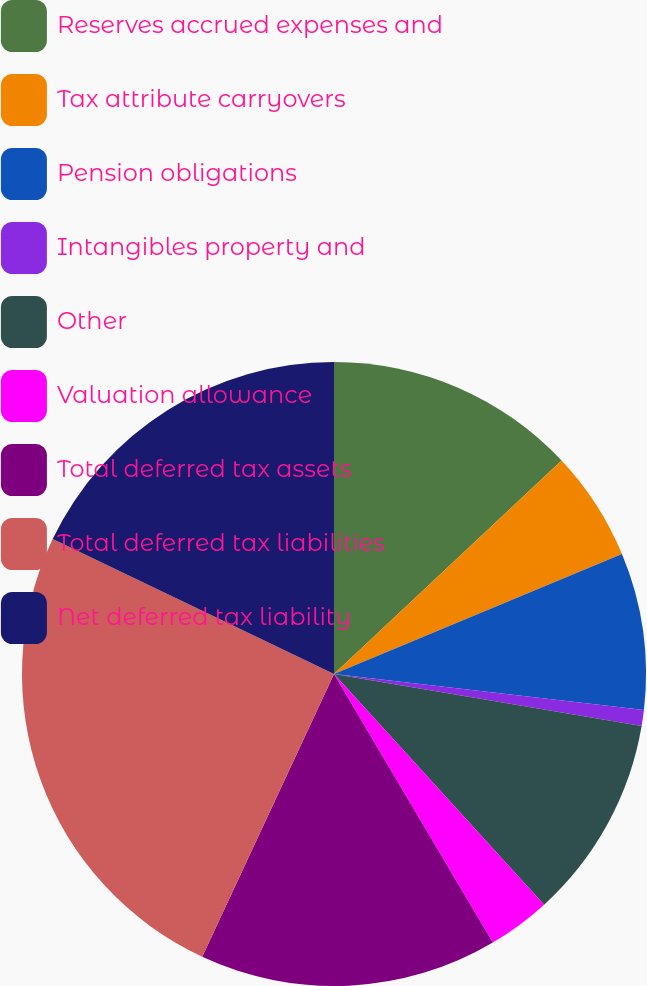Convert chart to OTSL. <chart><loc_0><loc_0><loc_500><loc_500><pie_chart><fcel>Reserves accrued expenses and<fcel>Tax attribute carryovers<fcel>Pension obligations<fcel>Intangibles property and<fcel>Other<fcel>Valuation allowance<fcel>Total deferred tax assets<fcel>Total deferred tax liabilities<fcel>Net deferred tax liability<nl><fcel>13.01%<fcel>5.7%<fcel>8.13%<fcel>0.83%<fcel>10.57%<fcel>3.26%<fcel>15.44%<fcel>25.18%<fcel>17.88%<nl></chart> 